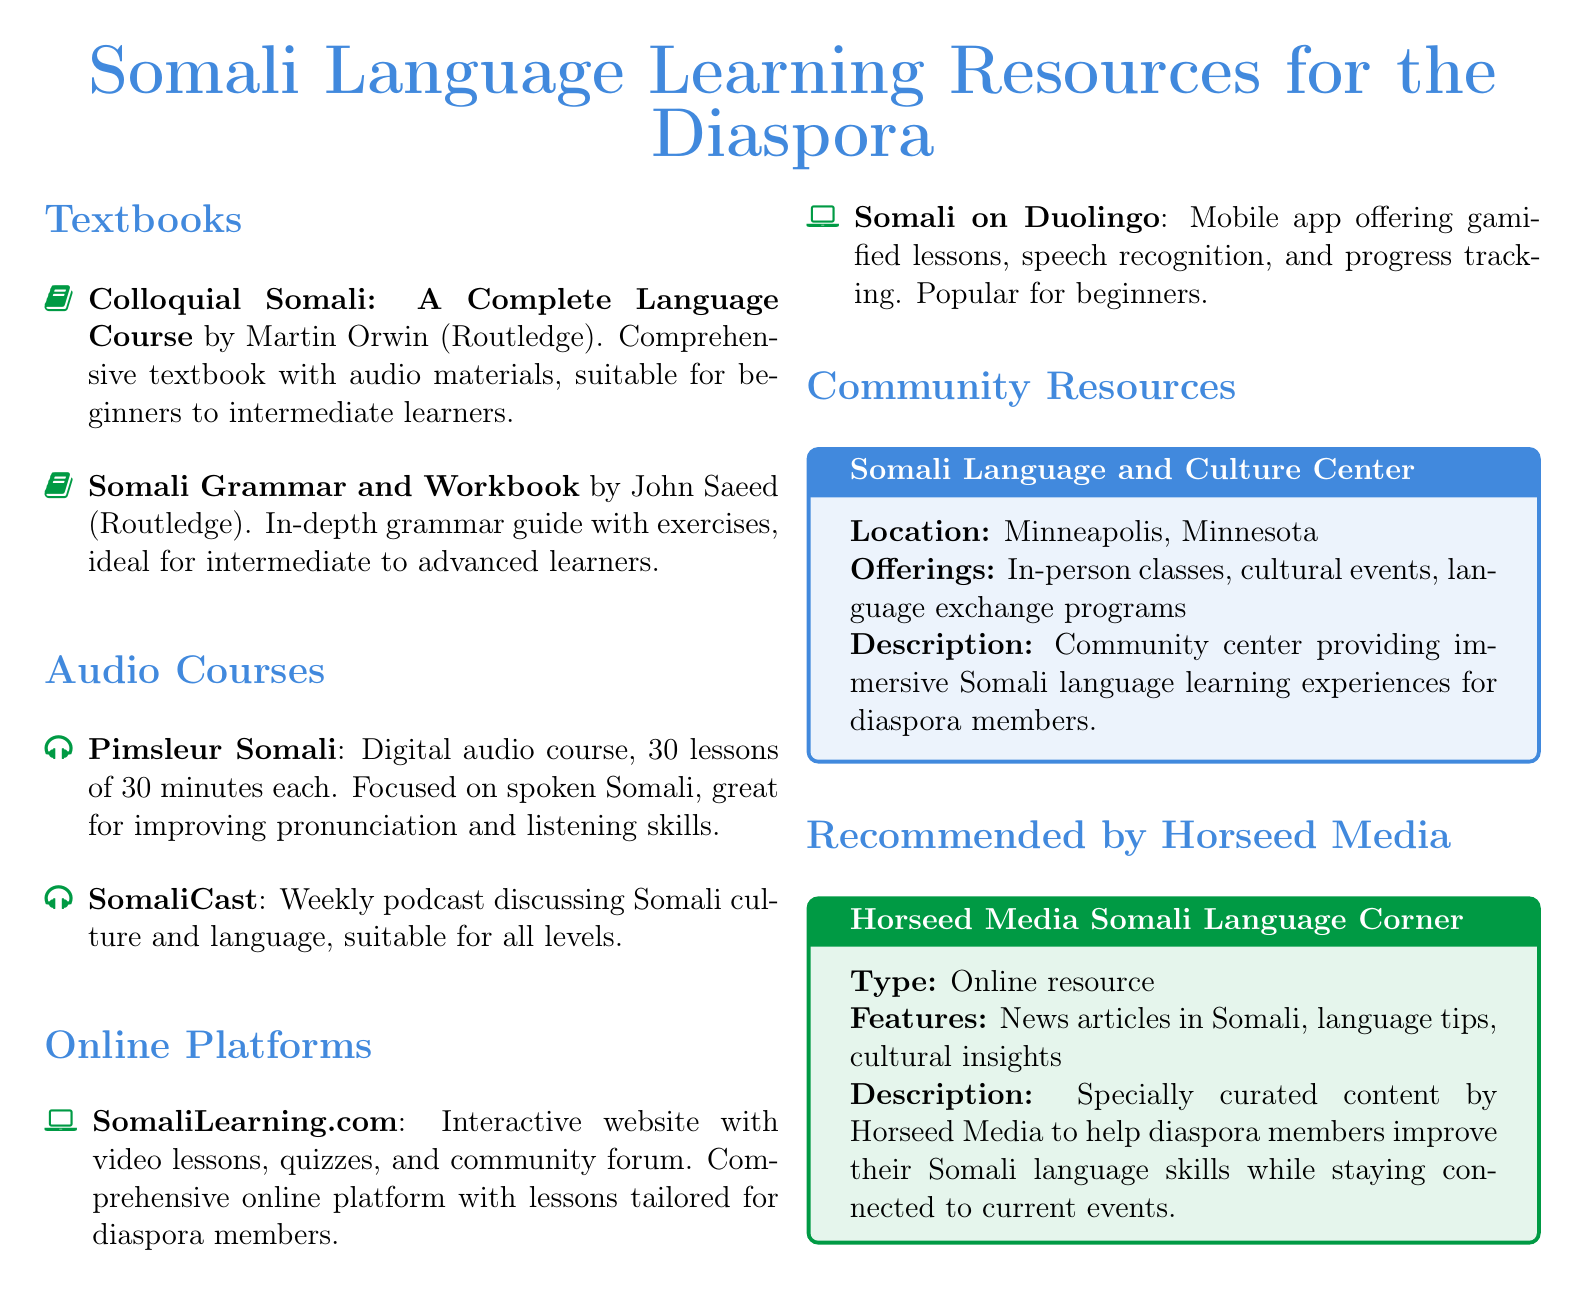What is the title of the first textbook listed? The title of the first textbook listed is a specific piece of information found in the document under the "Textbooks" section.
Answer: Colloquial Somali: A Complete Language Course Who authored the "Somali Grammar and Workbook"? This question requires identifying the author mentioned in the document for that specific textbook.
Answer: John Saeed How many lessons are in the Pimsleur Somali course? This is a straightforward retrieval of a numerical detail about the Pimsleur Somali course found in the "Audio Courses" section.
Answer: 30 lessons What type of resource is the Horseed Media Somali Language Corner? This question seeks to categorize the type of resource listed under the "Recommended by Horseed Media" section.
Answer: Online resource What is offered by the Somali Language and Culture Center? The offerings can be found in the description of the community resources section and include various language-learning experiences.
Answer: In-person classes Which online platform offers gamified lessons? This question involves connecting game-based learning features with the correct platform in the "Online Platforms" section of the document.
Answer: Somali on Duolingo 